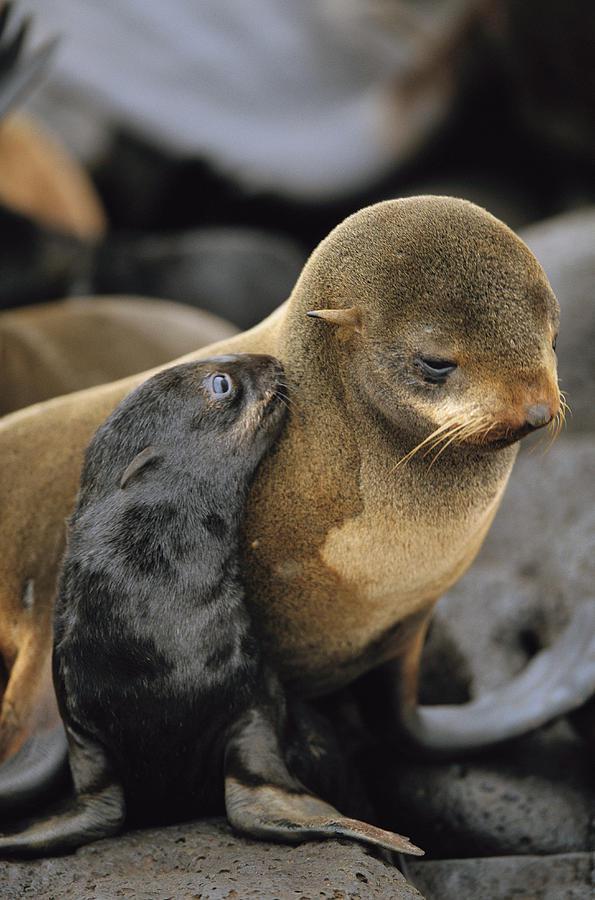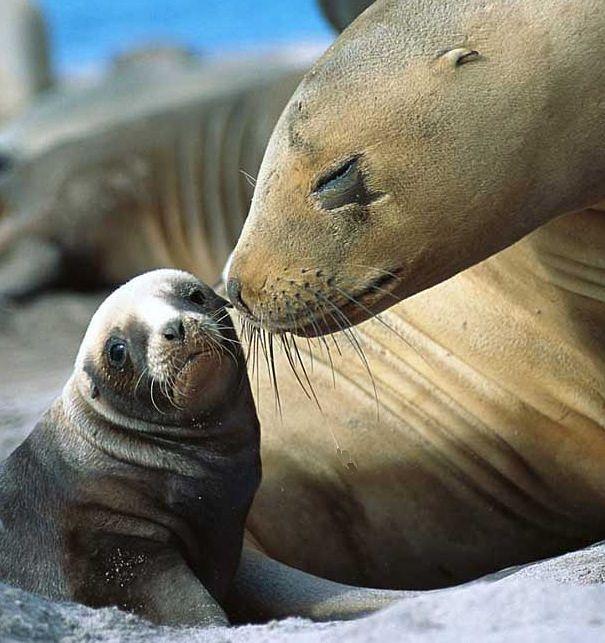The first image is the image on the left, the second image is the image on the right. For the images shown, is this caption "An adult seal extends its neck to nuzzle a baby seal with its nose in at least one image." true? Answer yes or no. Yes. The first image is the image on the left, the second image is the image on the right. Considering the images on both sides, is "Both images show a adult seal with a baby seal." valid? Answer yes or no. Yes. 